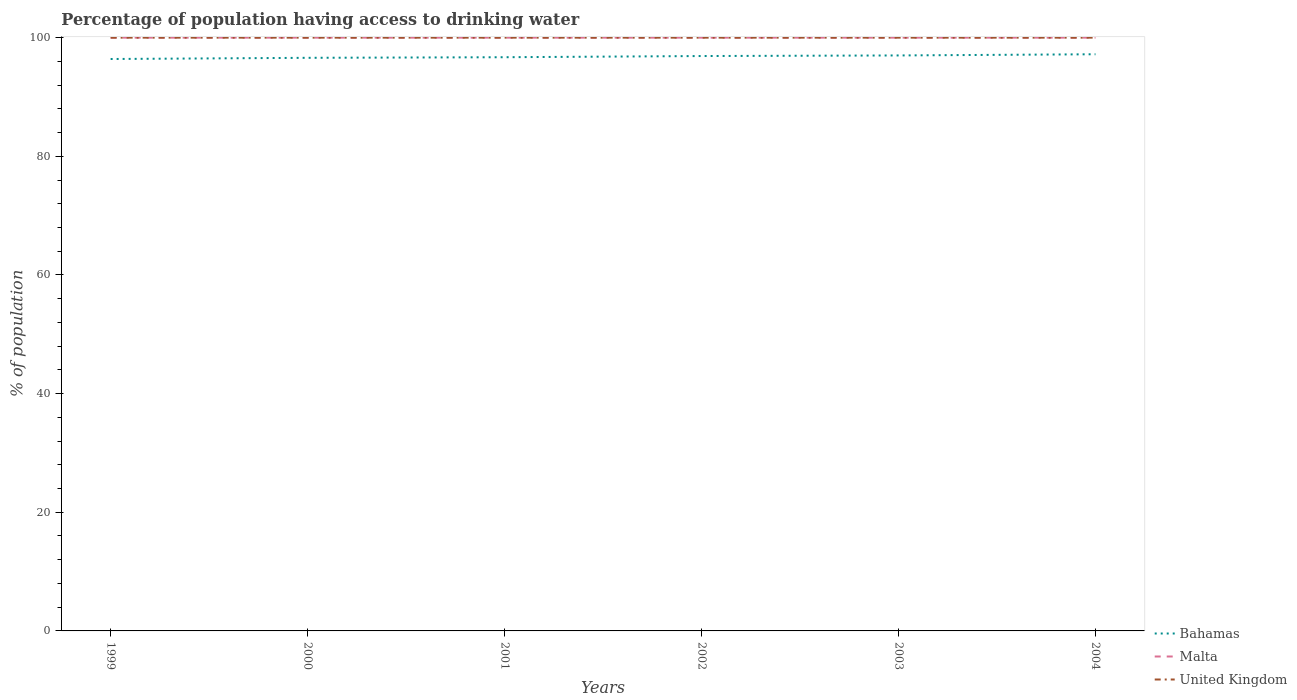How many different coloured lines are there?
Your response must be concise. 3. Is the number of lines equal to the number of legend labels?
Provide a succinct answer. Yes. Across all years, what is the maximum percentage of population having access to drinking water in Malta?
Your answer should be compact. 100. In which year was the percentage of population having access to drinking water in Bahamas maximum?
Ensure brevity in your answer.  1999. What is the difference between the highest and the second highest percentage of population having access to drinking water in Malta?
Provide a short and direct response. 0. What is the difference between the highest and the lowest percentage of population having access to drinking water in United Kingdom?
Your answer should be compact. 0. Is the percentage of population having access to drinking water in Malta strictly greater than the percentage of population having access to drinking water in United Kingdom over the years?
Your response must be concise. No. How many lines are there?
Keep it short and to the point. 3. Are the values on the major ticks of Y-axis written in scientific E-notation?
Provide a short and direct response. No. Where does the legend appear in the graph?
Ensure brevity in your answer.  Bottom right. How are the legend labels stacked?
Offer a terse response. Vertical. What is the title of the graph?
Offer a terse response. Percentage of population having access to drinking water. Does "Greenland" appear as one of the legend labels in the graph?
Offer a very short reply. No. What is the label or title of the X-axis?
Make the answer very short. Years. What is the label or title of the Y-axis?
Offer a very short reply. % of population. What is the % of population of Bahamas in 1999?
Provide a short and direct response. 96.4. What is the % of population of Malta in 1999?
Make the answer very short. 100. What is the % of population in United Kingdom in 1999?
Provide a short and direct response. 100. What is the % of population of Bahamas in 2000?
Provide a succinct answer. 96.6. What is the % of population in Bahamas in 2001?
Your response must be concise. 96.7. What is the % of population of United Kingdom in 2001?
Give a very brief answer. 100. What is the % of population of Bahamas in 2002?
Provide a succinct answer. 96.9. What is the % of population in Malta in 2002?
Keep it short and to the point. 100. What is the % of population in United Kingdom in 2002?
Give a very brief answer. 100. What is the % of population in Bahamas in 2003?
Offer a very short reply. 97. What is the % of population in Malta in 2003?
Offer a terse response. 100. What is the % of population of Bahamas in 2004?
Provide a short and direct response. 97.2. What is the % of population of United Kingdom in 2004?
Offer a terse response. 100. Across all years, what is the maximum % of population in Bahamas?
Offer a terse response. 97.2. Across all years, what is the minimum % of population of Bahamas?
Keep it short and to the point. 96.4. Across all years, what is the minimum % of population of Malta?
Give a very brief answer. 100. Across all years, what is the minimum % of population in United Kingdom?
Provide a succinct answer. 100. What is the total % of population in Bahamas in the graph?
Offer a very short reply. 580.8. What is the total % of population in Malta in the graph?
Your answer should be compact. 600. What is the total % of population of United Kingdom in the graph?
Offer a terse response. 600. What is the difference between the % of population of United Kingdom in 1999 and that in 2000?
Your answer should be very brief. 0. What is the difference between the % of population of Bahamas in 1999 and that in 2001?
Keep it short and to the point. -0.3. What is the difference between the % of population in Malta in 1999 and that in 2001?
Make the answer very short. 0. What is the difference between the % of population of Malta in 1999 and that in 2002?
Offer a terse response. 0. What is the difference between the % of population in Malta in 1999 and that in 2003?
Offer a very short reply. 0. What is the difference between the % of population of United Kingdom in 1999 and that in 2003?
Offer a terse response. 0. What is the difference between the % of population in Malta in 1999 and that in 2004?
Offer a terse response. 0. What is the difference between the % of population of United Kingdom in 1999 and that in 2004?
Provide a short and direct response. 0. What is the difference between the % of population in Malta in 2000 and that in 2001?
Provide a short and direct response. 0. What is the difference between the % of population of Bahamas in 2000 and that in 2002?
Keep it short and to the point. -0.3. What is the difference between the % of population in Malta in 2000 and that in 2002?
Ensure brevity in your answer.  0. What is the difference between the % of population of Malta in 2000 and that in 2003?
Offer a very short reply. 0. What is the difference between the % of population of United Kingdom in 2000 and that in 2003?
Your answer should be very brief. 0. What is the difference between the % of population of United Kingdom in 2000 and that in 2004?
Give a very brief answer. 0. What is the difference between the % of population of Malta in 2001 and that in 2002?
Keep it short and to the point. 0. What is the difference between the % of population in United Kingdom in 2001 and that in 2002?
Make the answer very short. 0. What is the difference between the % of population in Bahamas in 2001 and that in 2003?
Offer a very short reply. -0.3. What is the difference between the % of population of Malta in 2001 and that in 2003?
Provide a short and direct response. 0. What is the difference between the % of population of United Kingdom in 2001 and that in 2004?
Offer a very short reply. 0. What is the difference between the % of population of United Kingdom in 2002 and that in 2003?
Provide a succinct answer. 0. What is the difference between the % of population of Bahamas in 2002 and that in 2004?
Ensure brevity in your answer.  -0.3. What is the difference between the % of population of Malta in 2002 and that in 2004?
Make the answer very short. 0. What is the difference between the % of population of Malta in 2003 and that in 2004?
Provide a succinct answer. 0. What is the difference between the % of population of Bahamas in 1999 and the % of population of United Kingdom in 2000?
Keep it short and to the point. -3.6. What is the difference between the % of population in Malta in 1999 and the % of population in United Kingdom in 2000?
Keep it short and to the point. 0. What is the difference between the % of population of Bahamas in 1999 and the % of population of Malta in 2002?
Provide a short and direct response. -3.6. What is the difference between the % of population in Bahamas in 1999 and the % of population in United Kingdom in 2002?
Offer a terse response. -3.6. What is the difference between the % of population in Malta in 1999 and the % of population in United Kingdom in 2002?
Keep it short and to the point. 0. What is the difference between the % of population in Malta in 1999 and the % of population in United Kingdom in 2003?
Ensure brevity in your answer.  0. What is the difference between the % of population in Bahamas in 1999 and the % of population in Malta in 2004?
Provide a short and direct response. -3.6. What is the difference between the % of population in Malta in 1999 and the % of population in United Kingdom in 2004?
Provide a short and direct response. 0. What is the difference between the % of population of Bahamas in 2000 and the % of population of Malta in 2001?
Your answer should be very brief. -3.4. What is the difference between the % of population of Malta in 2000 and the % of population of United Kingdom in 2001?
Make the answer very short. 0. What is the difference between the % of population of Bahamas in 2000 and the % of population of United Kingdom in 2002?
Provide a succinct answer. -3.4. What is the difference between the % of population in Malta in 2000 and the % of population in United Kingdom in 2002?
Your answer should be compact. 0. What is the difference between the % of population of Bahamas in 2000 and the % of population of United Kingdom in 2003?
Offer a very short reply. -3.4. What is the difference between the % of population in Malta in 2000 and the % of population in United Kingdom in 2003?
Your response must be concise. 0. What is the difference between the % of population in Bahamas in 2000 and the % of population in United Kingdom in 2004?
Make the answer very short. -3.4. What is the difference between the % of population in Bahamas in 2001 and the % of population in Malta in 2002?
Ensure brevity in your answer.  -3.3. What is the difference between the % of population of Bahamas in 2001 and the % of population of United Kingdom in 2002?
Offer a very short reply. -3.3. What is the difference between the % of population of Malta in 2001 and the % of population of United Kingdom in 2002?
Ensure brevity in your answer.  0. What is the difference between the % of population in Bahamas in 2001 and the % of population in United Kingdom in 2003?
Offer a terse response. -3.3. What is the difference between the % of population of Malta in 2001 and the % of population of United Kingdom in 2003?
Provide a short and direct response. 0. What is the difference between the % of population of Malta in 2001 and the % of population of United Kingdom in 2004?
Give a very brief answer. 0. What is the difference between the % of population of Bahamas in 2002 and the % of population of Malta in 2003?
Provide a short and direct response. -3.1. What is the difference between the % of population in Malta in 2002 and the % of population in United Kingdom in 2003?
Ensure brevity in your answer.  0. What is the difference between the % of population of Bahamas in 2002 and the % of population of Malta in 2004?
Keep it short and to the point. -3.1. What is the difference between the % of population of Bahamas in 2002 and the % of population of United Kingdom in 2004?
Keep it short and to the point. -3.1. What is the difference between the % of population in Malta in 2002 and the % of population in United Kingdom in 2004?
Your response must be concise. 0. What is the difference between the % of population of Bahamas in 2003 and the % of population of Malta in 2004?
Give a very brief answer. -3. What is the difference between the % of population in Bahamas in 2003 and the % of population in United Kingdom in 2004?
Your response must be concise. -3. What is the average % of population in Bahamas per year?
Your answer should be very brief. 96.8. What is the average % of population of Malta per year?
Your answer should be compact. 100. In the year 1999, what is the difference between the % of population of Bahamas and % of population of Malta?
Offer a terse response. -3.6. In the year 2000, what is the difference between the % of population in Bahamas and % of population in Malta?
Offer a terse response. -3.4. In the year 2001, what is the difference between the % of population in Bahamas and % of population in Malta?
Keep it short and to the point. -3.3. In the year 2001, what is the difference between the % of population of Bahamas and % of population of United Kingdom?
Your answer should be very brief. -3.3. In the year 2001, what is the difference between the % of population of Malta and % of population of United Kingdom?
Your response must be concise. 0. In the year 2002, what is the difference between the % of population in Bahamas and % of population in United Kingdom?
Offer a terse response. -3.1. In the year 2003, what is the difference between the % of population in Bahamas and % of population in United Kingdom?
Give a very brief answer. -3. In the year 2003, what is the difference between the % of population of Malta and % of population of United Kingdom?
Your answer should be compact. 0. In the year 2004, what is the difference between the % of population in Bahamas and % of population in Malta?
Provide a succinct answer. -2.8. In the year 2004, what is the difference between the % of population of Bahamas and % of population of United Kingdom?
Keep it short and to the point. -2.8. What is the ratio of the % of population of Bahamas in 1999 to that in 2000?
Give a very brief answer. 1. What is the ratio of the % of population in Malta in 1999 to that in 2000?
Give a very brief answer. 1. What is the ratio of the % of population in United Kingdom in 1999 to that in 2000?
Offer a terse response. 1. What is the ratio of the % of population of United Kingdom in 1999 to that in 2001?
Your response must be concise. 1. What is the ratio of the % of population in United Kingdom in 1999 to that in 2002?
Your answer should be very brief. 1. What is the ratio of the % of population of Bahamas in 2000 to that in 2002?
Give a very brief answer. 1. What is the ratio of the % of population of United Kingdom in 2000 to that in 2002?
Provide a succinct answer. 1. What is the ratio of the % of population in Bahamas in 2000 to that in 2004?
Offer a very short reply. 0.99. What is the ratio of the % of population of United Kingdom in 2000 to that in 2004?
Offer a terse response. 1. What is the ratio of the % of population in Bahamas in 2001 to that in 2003?
Offer a very short reply. 1. What is the ratio of the % of population in Malta in 2001 to that in 2003?
Your answer should be very brief. 1. What is the ratio of the % of population in United Kingdom in 2001 to that in 2003?
Your response must be concise. 1. What is the ratio of the % of population in Bahamas in 2001 to that in 2004?
Provide a succinct answer. 0.99. What is the ratio of the % of population of Malta in 2001 to that in 2004?
Your response must be concise. 1. What is the ratio of the % of population of Malta in 2002 to that in 2003?
Your response must be concise. 1. What is the difference between the highest and the second highest % of population of Bahamas?
Give a very brief answer. 0.2. What is the difference between the highest and the second highest % of population in Malta?
Your answer should be compact. 0. What is the difference between the highest and the second highest % of population of United Kingdom?
Your response must be concise. 0. What is the difference between the highest and the lowest % of population in Malta?
Provide a short and direct response. 0. 